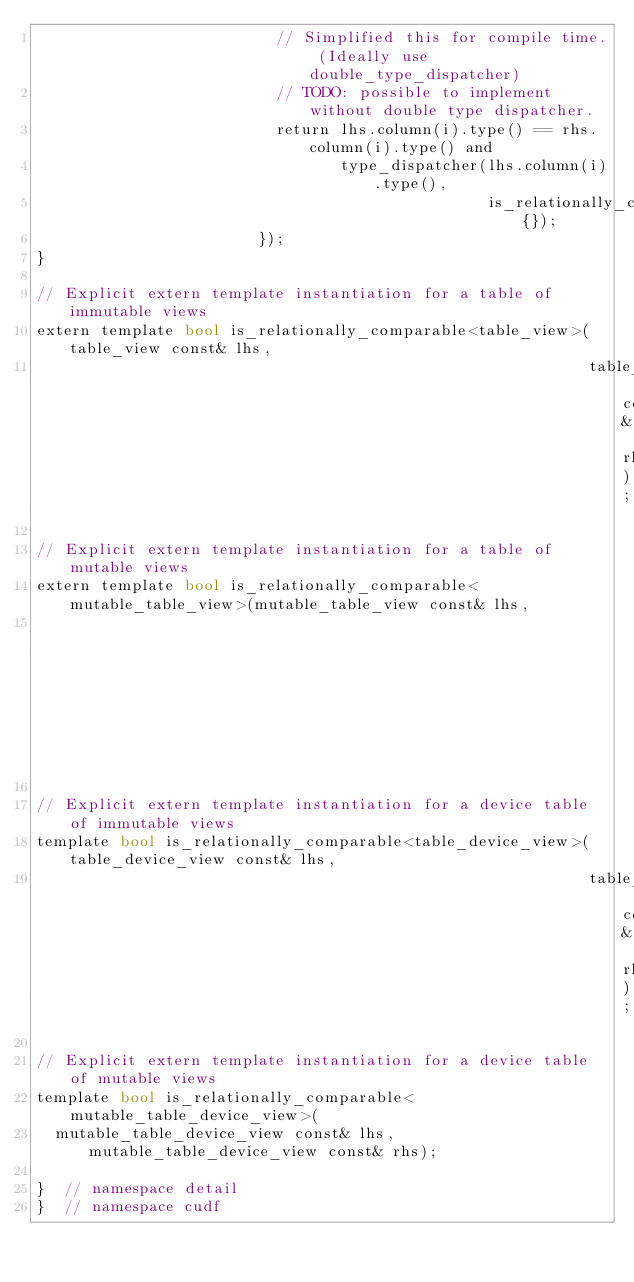<code> <loc_0><loc_0><loc_500><loc_500><_Cuda_>                          // Simplified this for compile time. (Ideally use double_type_dispatcher)
                          // TODO: possible to implement without double type dispatcher.
                          return lhs.column(i).type() == rhs.column(i).type() and
                                 type_dispatcher(lhs.column(i).type(),
                                                 is_relationally_comparable_impl{});
                        });
}

// Explicit extern template instantiation for a table of immutable views
extern template bool is_relationally_comparable<table_view>(table_view const& lhs,
                                                            table_view const& rhs);

// Explicit extern template instantiation for a table of mutable views
extern template bool is_relationally_comparable<mutable_table_view>(mutable_table_view const& lhs,
                                                                    mutable_table_view const& rhs);

// Explicit extern template instantiation for a device table of immutable views
template bool is_relationally_comparable<table_device_view>(table_device_view const& lhs,
                                                            table_device_view const& rhs);

// Explicit extern template instantiation for a device table of mutable views
template bool is_relationally_comparable<mutable_table_device_view>(
  mutable_table_device_view const& lhs, mutable_table_device_view const& rhs);

}  // namespace detail
}  // namespace cudf
</code> 